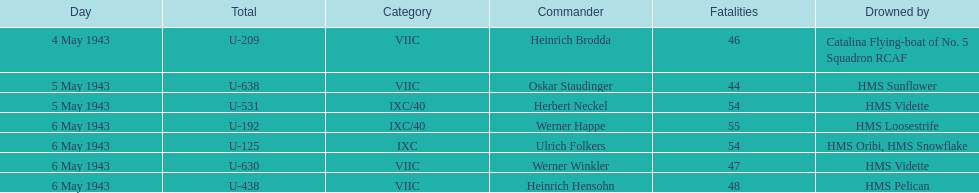Aside from oskar staudinger what was the name of the other captain of the u-boat loast on may 5? Herbert Neckel. 